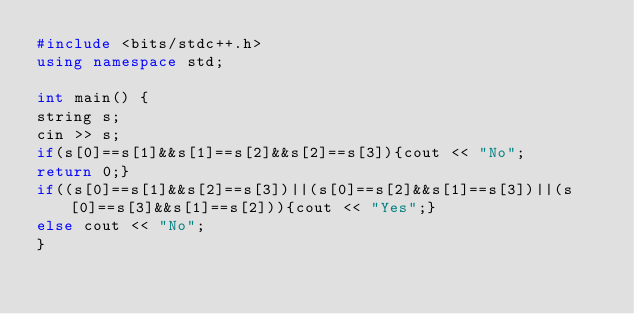Convert code to text. <code><loc_0><loc_0><loc_500><loc_500><_C++_>#include <bits/stdc++.h>
using namespace std;

int main() {
string s;
cin >> s;
if(s[0]==s[1]&&s[1]==s[2]&&s[2]==s[3]){cout << "No";
return 0;}
if((s[0]==s[1]&&s[2]==s[3])||(s[0]==s[2]&&s[1]==s[3])||(s[0]==s[3]&&s[1]==s[2])){cout << "Yes";}
else cout << "No";
}
</code> 